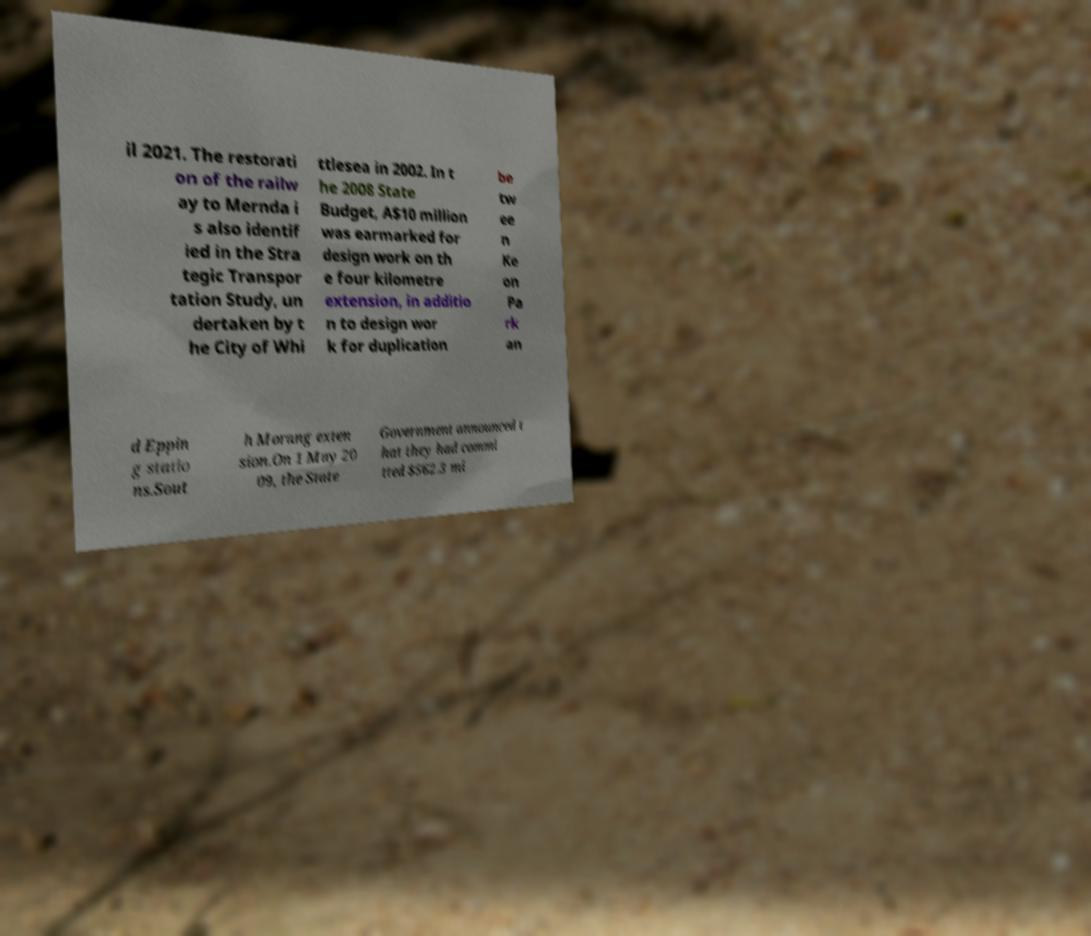Could you assist in decoding the text presented in this image and type it out clearly? il 2021. The restorati on of the railw ay to Mernda i s also identif ied in the Stra tegic Transpor tation Study, un dertaken by t he City of Whi ttlesea in 2002. In t he 2008 State Budget, A$10 million was earmarked for design work on th e four kilometre extension, in additio n to design wor k for duplication be tw ee n Ke on Pa rk an d Eppin g statio ns.Sout h Morang exten sion.On 1 May 20 09, the State Government announced t hat they had commi tted $562.3 mi 